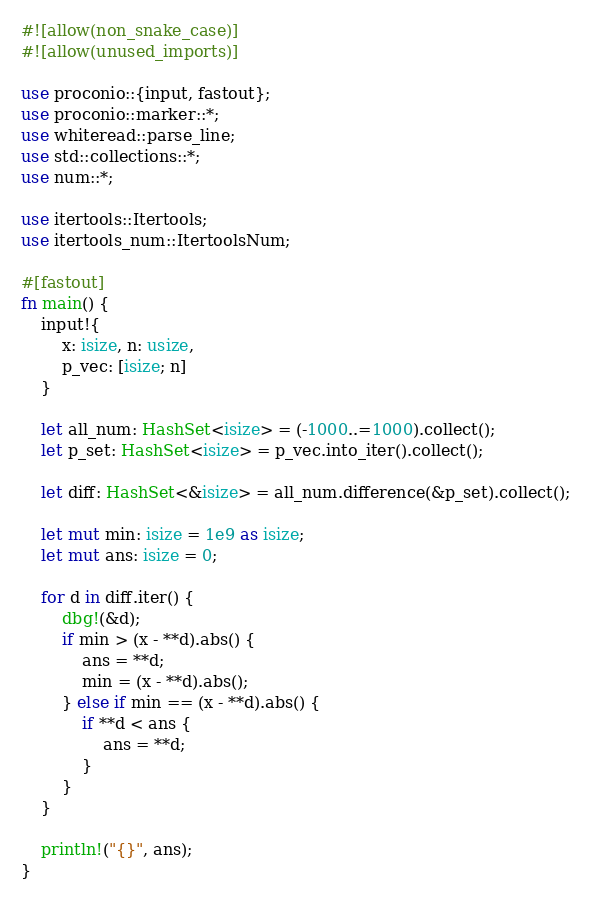<code> <loc_0><loc_0><loc_500><loc_500><_Rust_>#![allow(non_snake_case)]
#![allow(unused_imports)]

use proconio::{input, fastout};
use proconio::marker::*;
use whiteread::parse_line;
use std::collections::*;
use num::*;

use itertools::Itertools;
use itertools_num::ItertoolsNum;

#[fastout]
fn main() {
    input!{
        x: isize, n: usize,
        p_vec: [isize; n]
    }

    let all_num: HashSet<isize> = (-1000..=1000).collect();
    let p_set: HashSet<isize> = p_vec.into_iter().collect();

    let diff: HashSet<&isize> = all_num.difference(&p_set).collect();

    let mut min: isize = 1e9 as isize;
    let mut ans: isize = 0;

    for d in diff.iter() {
        dbg!(&d);
        if min > (x - **d).abs() {
            ans = **d;
            min = (x - **d).abs();
        } else if min == (x - **d).abs() {
            if **d < ans {
                ans = **d;
            }
        }
    }

    println!("{}", ans);
}
</code> 